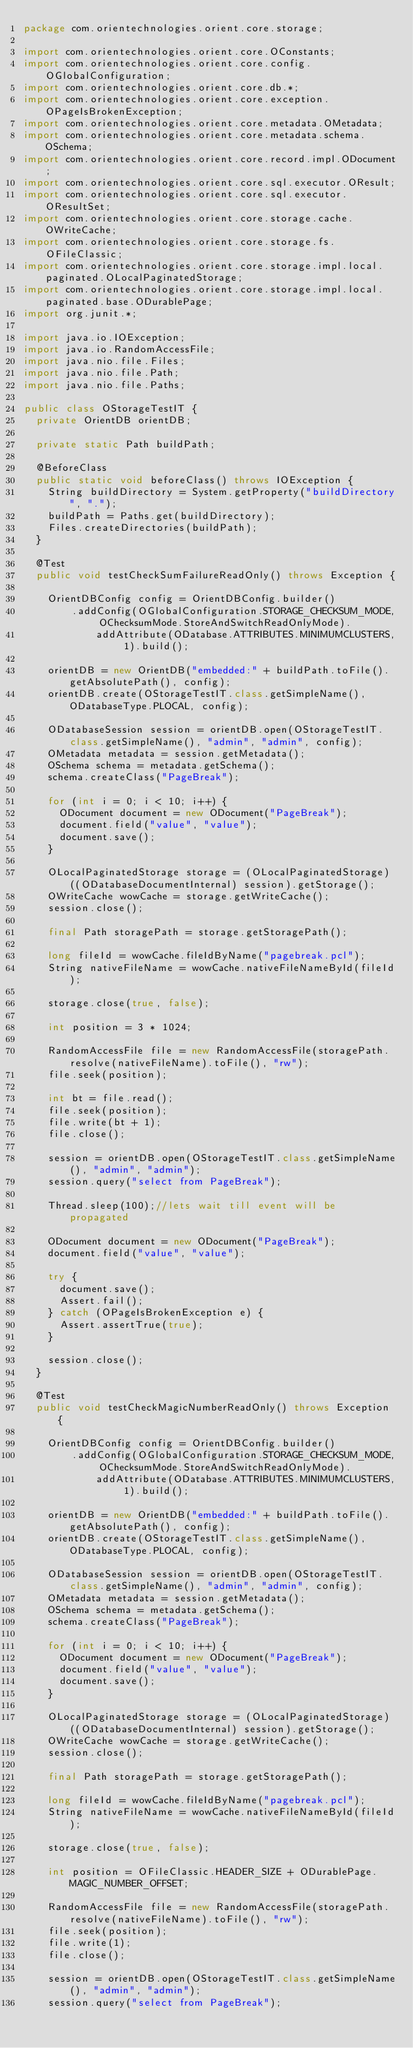<code> <loc_0><loc_0><loc_500><loc_500><_Java_>package com.orientechnologies.orient.core.storage;

import com.orientechnologies.orient.core.OConstants;
import com.orientechnologies.orient.core.config.OGlobalConfiguration;
import com.orientechnologies.orient.core.db.*;
import com.orientechnologies.orient.core.exception.OPageIsBrokenException;
import com.orientechnologies.orient.core.metadata.OMetadata;
import com.orientechnologies.orient.core.metadata.schema.OSchema;
import com.orientechnologies.orient.core.record.impl.ODocument;
import com.orientechnologies.orient.core.sql.executor.OResult;
import com.orientechnologies.orient.core.sql.executor.OResultSet;
import com.orientechnologies.orient.core.storage.cache.OWriteCache;
import com.orientechnologies.orient.core.storage.fs.OFileClassic;
import com.orientechnologies.orient.core.storage.impl.local.paginated.OLocalPaginatedStorage;
import com.orientechnologies.orient.core.storage.impl.local.paginated.base.ODurablePage;
import org.junit.*;

import java.io.IOException;
import java.io.RandomAccessFile;
import java.nio.file.Files;
import java.nio.file.Path;
import java.nio.file.Paths;

public class OStorageTestIT {
  private OrientDB orientDB;

  private static Path buildPath;

  @BeforeClass
  public static void beforeClass() throws IOException {
    String buildDirectory = System.getProperty("buildDirectory", ".");
    buildPath = Paths.get(buildDirectory);
    Files.createDirectories(buildPath);
  }

  @Test
  public void testCheckSumFailureReadOnly() throws Exception {

    OrientDBConfig config = OrientDBConfig.builder()
        .addConfig(OGlobalConfiguration.STORAGE_CHECKSUM_MODE, OChecksumMode.StoreAndSwitchReadOnlyMode).
            addAttribute(ODatabase.ATTRIBUTES.MINIMUMCLUSTERS, 1).build();

    orientDB = new OrientDB("embedded:" + buildPath.toFile().getAbsolutePath(), config);
    orientDB.create(OStorageTestIT.class.getSimpleName(), ODatabaseType.PLOCAL, config);

    ODatabaseSession session = orientDB.open(OStorageTestIT.class.getSimpleName(), "admin", "admin", config);
    OMetadata metadata = session.getMetadata();
    OSchema schema = metadata.getSchema();
    schema.createClass("PageBreak");

    for (int i = 0; i < 10; i++) {
      ODocument document = new ODocument("PageBreak");
      document.field("value", "value");
      document.save();
    }

    OLocalPaginatedStorage storage = (OLocalPaginatedStorage) ((ODatabaseDocumentInternal) session).getStorage();
    OWriteCache wowCache = storage.getWriteCache();
    session.close();

    final Path storagePath = storage.getStoragePath();

    long fileId = wowCache.fileIdByName("pagebreak.pcl");
    String nativeFileName = wowCache.nativeFileNameById(fileId);

    storage.close(true, false);

    int position = 3 * 1024;

    RandomAccessFile file = new RandomAccessFile(storagePath.resolve(nativeFileName).toFile(), "rw");
    file.seek(position);

    int bt = file.read();
    file.seek(position);
    file.write(bt + 1);
    file.close();

    session = orientDB.open(OStorageTestIT.class.getSimpleName(), "admin", "admin");
    session.query("select from PageBreak");

    Thread.sleep(100);//lets wait till event will be propagated

    ODocument document = new ODocument("PageBreak");
    document.field("value", "value");

    try {
      document.save();
      Assert.fail();
    } catch (OPageIsBrokenException e) {
      Assert.assertTrue(true);
    }

    session.close();
  }

  @Test
  public void testCheckMagicNumberReadOnly() throws Exception {

    OrientDBConfig config = OrientDBConfig.builder()
        .addConfig(OGlobalConfiguration.STORAGE_CHECKSUM_MODE, OChecksumMode.StoreAndSwitchReadOnlyMode).
            addAttribute(ODatabase.ATTRIBUTES.MINIMUMCLUSTERS, 1).build();

    orientDB = new OrientDB("embedded:" + buildPath.toFile().getAbsolutePath(), config);
    orientDB.create(OStorageTestIT.class.getSimpleName(), ODatabaseType.PLOCAL, config);

    ODatabaseSession session = orientDB.open(OStorageTestIT.class.getSimpleName(), "admin", "admin", config);
    OMetadata metadata = session.getMetadata();
    OSchema schema = metadata.getSchema();
    schema.createClass("PageBreak");

    for (int i = 0; i < 10; i++) {
      ODocument document = new ODocument("PageBreak");
      document.field("value", "value");
      document.save();
    }

    OLocalPaginatedStorage storage = (OLocalPaginatedStorage) ((ODatabaseDocumentInternal) session).getStorage();
    OWriteCache wowCache = storage.getWriteCache();
    session.close();

    final Path storagePath = storage.getStoragePath();

    long fileId = wowCache.fileIdByName("pagebreak.pcl");
    String nativeFileName = wowCache.nativeFileNameById(fileId);

    storage.close(true, false);

    int position = OFileClassic.HEADER_SIZE + ODurablePage.MAGIC_NUMBER_OFFSET;

    RandomAccessFile file = new RandomAccessFile(storagePath.resolve(nativeFileName).toFile(), "rw");
    file.seek(position);
    file.write(1);
    file.close();

    session = orientDB.open(OStorageTestIT.class.getSimpleName(), "admin", "admin");
    session.query("select from PageBreak");
</code> 